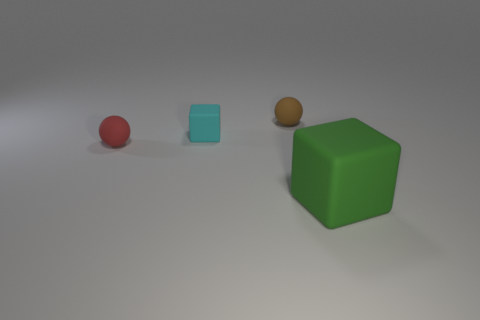Add 1 purple rubber cylinders. How many objects exist? 5 Add 2 cyan rubber things. How many cyan rubber things are left? 3 Add 4 purple metal objects. How many purple metal objects exist? 4 Subtract 0 brown cylinders. How many objects are left? 4 Subtract all matte blocks. Subtract all red matte balls. How many objects are left? 1 